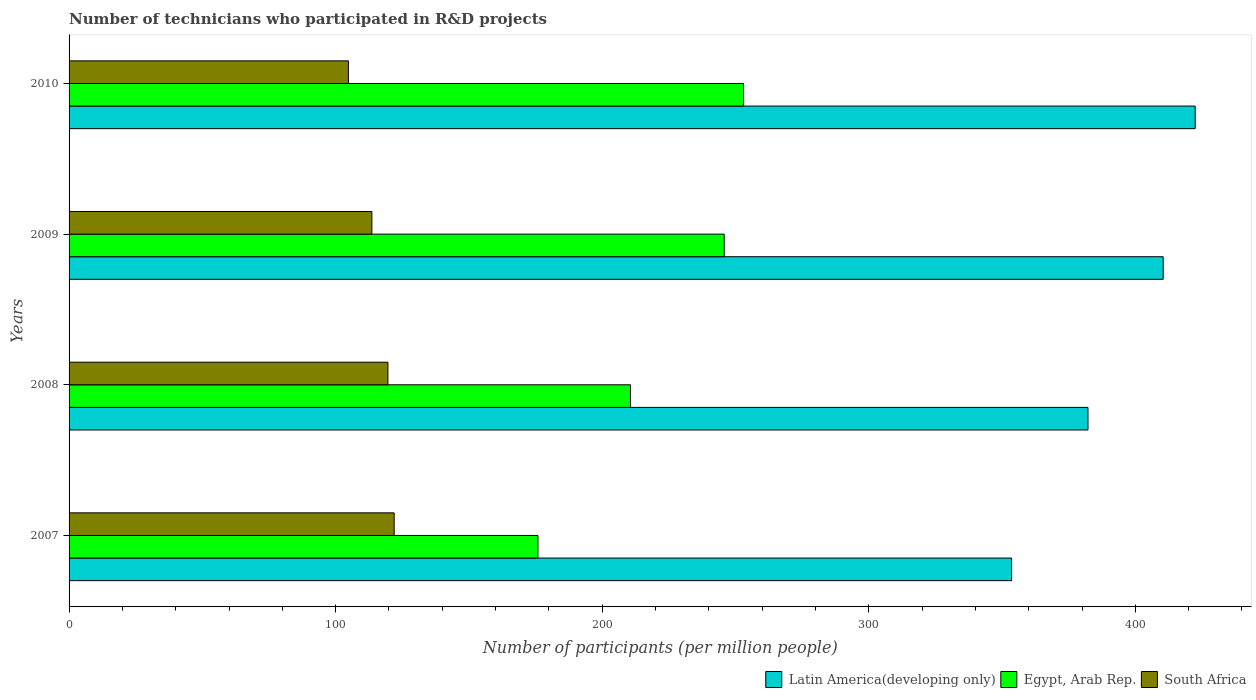How many different coloured bars are there?
Offer a terse response. 3. How many groups of bars are there?
Your response must be concise. 4. How many bars are there on the 4th tick from the top?
Keep it short and to the point. 3. In how many cases, is the number of bars for a given year not equal to the number of legend labels?
Your answer should be very brief. 0. What is the number of technicians who participated in R&D projects in Latin America(developing only) in 2007?
Provide a succinct answer. 353.59. Across all years, what is the maximum number of technicians who participated in R&D projects in Latin America(developing only)?
Keep it short and to the point. 422.45. Across all years, what is the minimum number of technicians who participated in R&D projects in Egypt, Arab Rep.?
Give a very brief answer. 175.89. In which year was the number of technicians who participated in R&D projects in South Africa minimum?
Give a very brief answer. 2010. What is the total number of technicians who participated in R&D projects in South Africa in the graph?
Give a very brief answer. 459.95. What is the difference between the number of technicians who participated in R&D projects in Egypt, Arab Rep. in 2008 and that in 2010?
Offer a terse response. -42.42. What is the difference between the number of technicians who participated in R&D projects in Latin America(developing only) in 2009 and the number of technicians who participated in R&D projects in Egypt, Arab Rep. in 2008?
Make the answer very short. 199.85. What is the average number of technicians who participated in R&D projects in Latin America(developing only) per year?
Make the answer very short. 392.17. In the year 2008, what is the difference between the number of technicians who participated in R&D projects in Latin America(developing only) and number of technicians who participated in R&D projects in South Africa?
Your answer should be very brief. 262.61. In how many years, is the number of technicians who participated in R&D projects in Latin America(developing only) greater than 320 ?
Offer a very short reply. 4. What is the ratio of the number of technicians who participated in R&D projects in Latin America(developing only) in 2009 to that in 2010?
Give a very brief answer. 0.97. What is the difference between the highest and the second highest number of technicians who participated in R&D projects in Latin America(developing only)?
Your response must be concise. 12.01. What is the difference between the highest and the lowest number of technicians who participated in R&D projects in Latin America(developing only)?
Your response must be concise. 68.86. In how many years, is the number of technicians who participated in R&D projects in Latin America(developing only) greater than the average number of technicians who participated in R&D projects in Latin America(developing only) taken over all years?
Ensure brevity in your answer.  2. What does the 3rd bar from the top in 2007 represents?
Offer a terse response. Latin America(developing only). What does the 2nd bar from the bottom in 2007 represents?
Provide a short and direct response. Egypt, Arab Rep. Is it the case that in every year, the sum of the number of technicians who participated in R&D projects in South Africa and number of technicians who participated in R&D projects in Egypt, Arab Rep. is greater than the number of technicians who participated in R&D projects in Latin America(developing only)?
Ensure brevity in your answer.  No. How many bars are there?
Your answer should be very brief. 12. Are all the bars in the graph horizontal?
Give a very brief answer. Yes. What is the difference between two consecutive major ticks on the X-axis?
Provide a succinct answer. 100. Where does the legend appear in the graph?
Keep it short and to the point. Bottom right. How are the legend labels stacked?
Make the answer very short. Horizontal. What is the title of the graph?
Keep it short and to the point. Number of technicians who participated in R&D projects. What is the label or title of the X-axis?
Make the answer very short. Number of participants (per million people). What is the Number of participants (per million people) of Latin America(developing only) in 2007?
Offer a very short reply. 353.59. What is the Number of participants (per million people) of Egypt, Arab Rep. in 2007?
Offer a terse response. 175.89. What is the Number of participants (per million people) of South Africa in 2007?
Ensure brevity in your answer.  121.96. What is the Number of participants (per million people) of Latin America(developing only) in 2008?
Offer a very short reply. 382.22. What is the Number of participants (per million people) in Egypt, Arab Rep. in 2008?
Provide a short and direct response. 210.6. What is the Number of participants (per million people) of South Africa in 2008?
Your answer should be compact. 119.61. What is the Number of participants (per million people) in Latin America(developing only) in 2009?
Your answer should be very brief. 410.44. What is the Number of participants (per million people) of Egypt, Arab Rep. in 2009?
Give a very brief answer. 245.77. What is the Number of participants (per million people) in South Africa in 2009?
Offer a terse response. 113.59. What is the Number of participants (per million people) of Latin America(developing only) in 2010?
Provide a succinct answer. 422.45. What is the Number of participants (per million people) in Egypt, Arab Rep. in 2010?
Ensure brevity in your answer.  253.02. What is the Number of participants (per million people) in South Africa in 2010?
Provide a succinct answer. 104.79. Across all years, what is the maximum Number of participants (per million people) in Latin America(developing only)?
Provide a short and direct response. 422.45. Across all years, what is the maximum Number of participants (per million people) of Egypt, Arab Rep.?
Your answer should be very brief. 253.02. Across all years, what is the maximum Number of participants (per million people) in South Africa?
Offer a terse response. 121.96. Across all years, what is the minimum Number of participants (per million people) in Latin America(developing only)?
Offer a very short reply. 353.59. Across all years, what is the minimum Number of participants (per million people) in Egypt, Arab Rep.?
Offer a very short reply. 175.89. Across all years, what is the minimum Number of participants (per million people) of South Africa?
Provide a short and direct response. 104.79. What is the total Number of participants (per million people) in Latin America(developing only) in the graph?
Your answer should be very brief. 1568.7. What is the total Number of participants (per million people) of Egypt, Arab Rep. in the graph?
Keep it short and to the point. 885.27. What is the total Number of participants (per million people) in South Africa in the graph?
Offer a very short reply. 459.95. What is the difference between the Number of participants (per million people) in Latin America(developing only) in 2007 and that in 2008?
Your response must be concise. -28.64. What is the difference between the Number of participants (per million people) of Egypt, Arab Rep. in 2007 and that in 2008?
Ensure brevity in your answer.  -34.71. What is the difference between the Number of participants (per million people) in South Africa in 2007 and that in 2008?
Offer a very short reply. 2.34. What is the difference between the Number of participants (per million people) of Latin America(developing only) in 2007 and that in 2009?
Offer a very short reply. -56.85. What is the difference between the Number of participants (per million people) of Egypt, Arab Rep. in 2007 and that in 2009?
Ensure brevity in your answer.  -69.88. What is the difference between the Number of participants (per million people) in South Africa in 2007 and that in 2009?
Provide a succinct answer. 8.37. What is the difference between the Number of participants (per million people) in Latin America(developing only) in 2007 and that in 2010?
Give a very brief answer. -68.86. What is the difference between the Number of participants (per million people) in Egypt, Arab Rep. in 2007 and that in 2010?
Make the answer very short. -77.13. What is the difference between the Number of participants (per million people) in South Africa in 2007 and that in 2010?
Make the answer very short. 17.16. What is the difference between the Number of participants (per million people) of Latin America(developing only) in 2008 and that in 2009?
Your answer should be very brief. -28.22. What is the difference between the Number of participants (per million people) in Egypt, Arab Rep. in 2008 and that in 2009?
Make the answer very short. -35.17. What is the difference between the Number of participants (per million people) of South Africa in 2008 and that in 2009?
Offer a terse response. 6.02. What is the difference between the Number of participants (per million people) in Latin America(developing only) in 2008 and that in 2010?
Give a very brief answer. -40.22. What is the difference between the Number of participants (per million people) in Egypt, Arab Rep. in 2008 and that in 2010?
Offer a very short reply. -42.42. What is the difference between the Number of participants (per million people) in South Africa in 2008 and that in 2010?
Provide a succinct answer. 14.82. What is the difference between the Number of participants (per million people) of Latin America(developing only) in 2009 and that in 2010?
Ensure brevity in your answer.  -12.01. What is the difference between the Number of participants (per million people) of Egypt, Arab Rep. in 2009 and that in 2010?
Provide a succinct answer. -7.25. What is the difference between the Number of participants (per million people) of South Africa in 2009 and that in 2010?
Your response must be concise. 8.8. What is the difference between the Number of participants (per million people) of Latin America(developing only) in 2007 and the Number of participants (per million people) of Egypt, Arab Rep. in 2008?
Give a very brief answer. 142.99. What is the difference between the Number of participants (per million people) of Latin America(developing only) in 2007 and the Number of participants (per million people) of South Africa in 2008?
Provide a short and direct response. 233.97. What is the difference between the Number of participants (per million people) in Egypt, Arab Rep. in 2007 and the Number of participants (per million people) in South Africa in 2008?
Your answer should be compact. 56.28. What is the difference between the Number of participants (per million people) in Latin America(developing only) in 2007 and the Number of participants (per million people) in Egypt, Arab Rep. in 2009?
Offer a terse response. 107.82. What is the difference between the Number of participants (per million people) of Latin America(developing only) in 2007 and the Number of participants (per million people) of South Africa in 2009?
Make the answer very short. 240. What is the difference between the Number of participants (per million people) in Egypt, Arab Rep. in 2007 and the Number of participants (per million people) in South Africa in 2009?
Offer a terse response. 62.3. What is the difference between the Number of participants (per million people) in Latin America(developing only) in 2007 and the Number of participants (per million people) in Egypt, Arab Rep. in 2010?
Your response must be concise. 100.57. What is the difference between the Number of participants (per million people) of Latin America(developing only) in 2007 and the Number of participants (per million people) of South Africa in 2010?
Provide a short and direct response. 248.79. What is the difference between the Number of participants (per million people) of Egypt, Arab Rep. in 2007 and the Number of participants (per million people) of South Africa in 2010?
Your response must be concise. 71.1. What is the difference between the Number of participants (per million people) in Latin America(developing only) in 2008 and the Number of participants (per million people) in Egypt, Arab Rep. in 2009?
Your answer should be very brief. 136.46. What is the difference between the Number of participants (per million people) in Latin America(developing only) in 2008 and the Number of participants (per million people) in South Africa in 2009?
Offer a very short reply. 268.63. What is the difference between the Number of participants (per million people) in Egypt, Arab Rep. in 2008 and the Number of participants (per million people) in South Africa in 2009?
Ensure brevity in your answer.  97.01. What is the difference between the Number of participants (per million people) in Latin America(developing only) in 2008 and the Number of participants (per million people) in Egypt, Arab Rep. in 2010?
Ensure brevity in your answer.  129.2. What is the difference between the Number of participants (per million people) in Latin America(developing only) in 2008 and the Number of participants (per million people) in South Africa in 2010?
Ensure brevity in your answer.  277.43. What is the difference between the Number of participants (per million people) of Egypt, Arab Rep. in 2008 and the Number of participants (per million people) of South Africa in 2010?
Offer a very short reply. 105.8. What is the difference between the Number of participants (per million people) of Latin America(developing only) in 2009 and the Number of participants (per million people) of Egypt, Arab Rep. in 2010?
Provide a short and direct response. 157.42. What is the difference between the Number of participants (per million people) in Latin America(developing only) in 2009 and the Number of participants (per million people) in South Africa in 2010?
Your answer should be very brief. 305.65. What is the difference between the Number of participants (per million people) of Egypt, Arab Rep. in 2009 and the Number of participants (per million people) of South Africa in 2010?
Ensure brevity in your answer.  140.97. What is the average Number of participants (per million people) in Latin America(developing only) per year?
Your answer should be compact. 392.17. What is the average Number of participants (per million people) in Egypt, Arab Rep. per year?
Make the answer very short. 221.32. What is the average Number of participants (per million people) of South Africa per year?
Provide a succinct answer. 114.99. In the year 2007, what is the difference between the Number of participants (per million people) of Latin America(developing only) and Number of participants (per million people) of Egypt, Arab Rep.?
Provide a succinct answer. 177.7. In the year 2007, what is the difference between the Number of participants (per million people) of Latin America(developing only) and Number of participants (per million people) of South Africa?
Provide a succinct answer. 231.63. In the year 2007, what is the difference between the Number of participants (per million people) of Egypt, Arab Rep. and Number of participants (per million people) of South Africa?
Your answer should be very brief. 53.93. In the year 2008, what is the difference between the Number of participants (per million people) in Latin America(developing only) and Number of participants (per million people) in Egypt, Arab Rep.?
Your answer should be very brief. 171.63. In the year 2008, what is the difference between the Number of participants (per million people) in Latin America(developing only) and Number of participants (per million people) in South Africa?
Keep it short and to the point. 262.61. In the year 2008, what is the difference between the Number of participants (per million people) in Egypt, Arab Rep. and Number of participants (per million people) in South Africa?
Your answer should be compact. 90.98. In the year 2009, what is the difference between the Number of participants (per million people) in Latin America(developing only) and Number of participants (per million people) in Egypt, Arab Rep.?
Make the answer very short. 164.68. In the year 2009, what is the difference between the Number of participants (per million people) of Latin America(developing only) and Number of participants (per million people) of South Africa?
Provide a succinct answer. 296.85. In the year 2009, what is the difference between the Number of participants (per million people) of Egypt, Arab Rep. and Number of participants (per million people) of South Africa?
Give a very brief answer. 132.18. In the year 2010, what is the difference between the Number of participants (per million people) of Latin America(developing only) and Number of participants (per million people) of Egypt, Arab Rep.?
Offer a terse response. 169.43. In the year 2010, what is the difference between the Number of participants (per million people) of Latin America(developing only) and Number of participants (per million people) of South Africa?
Offer a terse response. 317.65. In the year 2010, what is the difference between the Number of participants (per million people) in Egypt, Arab Rep. and Number of participants (per million people) in South Africa?
Provide a succinct answer. 148.23. What is the ratio of the Number of participants (per million people) of Latin America(developing only) in 2007 to that in 2008?
Make the answer very short. 0.93. What is the ratio of the Number of participants (per million people) in Egypt, Arab Rep. in 2007 to that in 2008?
Your answer should be very brief. 0.84. What is the ratio of the Number of participants (per million people) in South Africa in 2007 to that in 2008?
Keep it short and to the point. 1.02. What is the ratio of the Number of participants (per million people) of Latin America(developing only) in 2007 to that in 2009?
Give a very brief answer. 0.86. What is the ratio of the Number of participants (per million people) of Egypt, Arab Rep. in 2007 to that in 2009?
Give a very brief answer. 0.72. What is the ratio of the Number of participants (per million people) in South Africa in 2007 to that in 2009?
Offer a very short reply. 1.07. What is the ratio of the Number of participants (per million people) in Latin America(developing only) in 2007 to that in 2010?
Provide a succinct answer. 0.84. What is the ratio of the Number of participants (per million people) of Egypt, Arab Rep. in 2007 to that in 2010?
Provide a short and direct response. 0.7. What is the ratio of the Number of participants (per million people) in South Africa in 2007 to that in 2010?
Keep it short and to the point. 1.16. What is the ratio of the Number of participants (per million people) in Latin America(developing only) in 2008 to that in 2009?
Provide a succinct answer. 0.93. What is the ratio of the Number of participants (per million people) in Egypt, Arab Rep. in 2008 to that in 2009?
Offer a very short reply. 0.86. What is the ratio of the Number of participants (per million people) of South Africa in 2008 to that in 2009?
Offer a very short reply. 1.05. What is the ratio of the Number of participants (per million people) in Latin America(developing only) in 2008 to that in 2010?
Offer a terse response. 0.9. What is the ratio of the Number of participants (per million people) of Egypt, Arab Rep. in 2008 to that in 2010?
Offer a very short reply. 0.83. What is the ratio of the Number of participants (per million people) of South Africa in 2008 to that in 2010?
Keep it short and to the point. 1.14. What is the ratio of the Number of participants (per million people) of Latin America(developing only) in 2009 to that in 2010?
Your response must be concise. 0.97. What is the ratio of the Number of participants (per million people) of Egypt, Arab Rep. in 2009 to that in 2010?
Offer a very short reply. 0.97. What is the ratio of the Number of participants (per million people) of South Africa in 2009 to that in 2010?
Offer a very short reply. 1.08. What is the difference between the highest and the second highest Number of participants (per million people) of Latin America(developing only)?
Ensure brevity in your answer.  12.01. What is the difference between the highest and the second highest Number of participants (per million people) in Egypt, Arab Rep.?
Offer a very short reply. 7.25. What is the difference between the highest and the second highest Number of participants (per million people) of South Africa?
Give a very brief answer. 2.34. What is the difference between the highest and the lowest Number of participants (per million people) of Latin America(developing only)?
Provide a succinct answer. 68.86. What is the difference between the highest and the lowest Number of participants (per million people) in Egypt, Arab Rep.?
Your response must be concise. 77.13. What is the difference between the highest and the lowest Number of participants (per million people) of South Africa?
Provide a succinct answer. 17.16. 